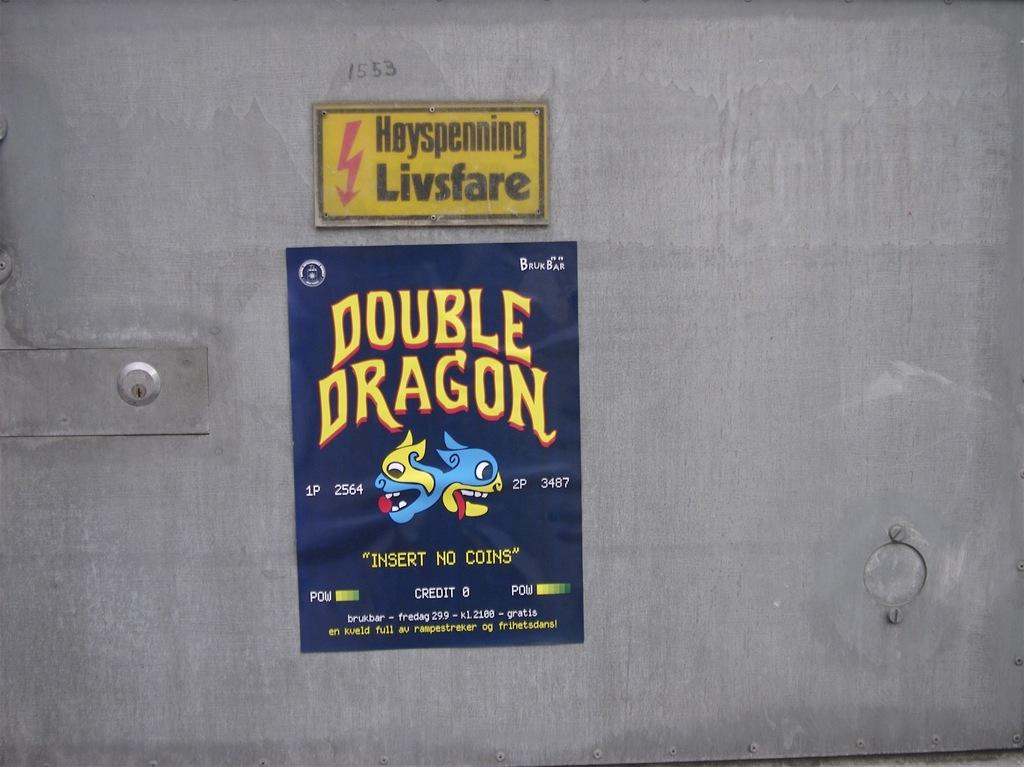<image>
Create a compact narrative representing the image presented. A double dragon sticker says insert no coins. 